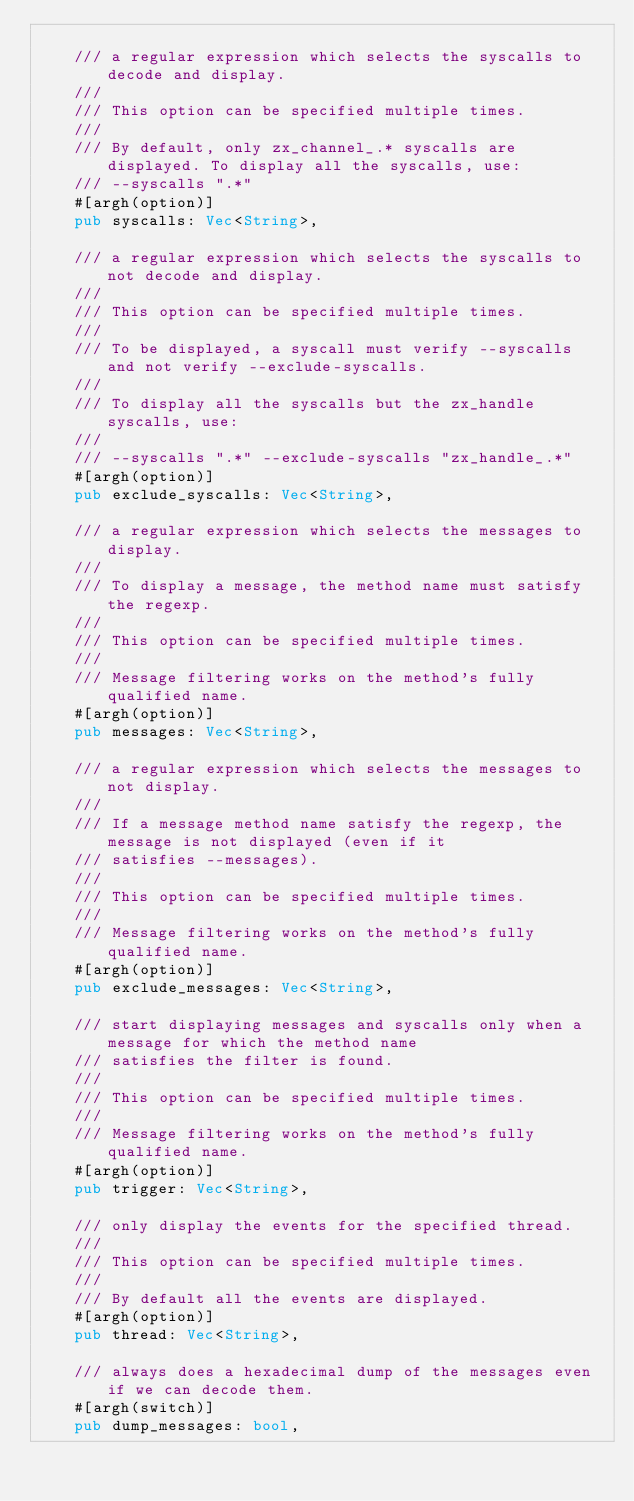Convert code to text. <code><loc_0><loc_0><loc_500><loc_500><_Rust_>
    /// a regular expression which selects the syscalls to decode and display.
    ///
    /// This option can be specified multiple times.
    ///
    /// By default, only zx_channel_.* syscalls are displayed. To display all the syscalls, use:
    /// --syscalls ".*"
    #[argh(option)]
    pub syscalls: Vec<String>,

    /// a regular expression which selects the syscalls to not decode and display.
    ///
    /// This option can be specified multiple times.
    ///
    /// To be displayed, a syscall must verify --syscalls and not verify --exclude-syscalls.
    ///
    /// To display all the syscalls but the zx_handle syscalls, use:
    ///
    /// --syscalls ".*" --exclude-syscalls "zx_handle_.*"
    #[argh(option)]
    pub exclude_syscalls: Vec<String>,

    /// a regular expression which selects the messages to display.
    ///
    /// To display a message, the method name must satisfy the regexp.
    ///
    /// This option can be specified multiple times.
    ///
    /// Message filtering works on the method's fully qualified name.
    #[argh(option)]
    pub messages: Vec<String>,

    /// a regular expression which selects the messages to not display.
    ///
    /// If a message method name satisfy the regexp, the message is not displayed (even if it
    /// satisfies --messages).
    ///
    /// This option can be specified multiple times.
    ///
    /// Message filtering works on the method's fully qualified name.
    #[argh(option)]
    pub exclude_messages: Vec<String>,

    /// start displaying messages and syscalls only when a message for which the method name
    /// satisfies the filter is found.
    ///
    /// This option can be specified multiple times.
    ///
    /// Message filtering works on the method's fully qualified name.
    #[argh(option)]
    pub trigger: Vec<String>,

    /// only display the events for the specified thread.
    ///
    /// This option can be specified multiple times.
    ///
    /// By default all the events are displayed.
    #[argh(option)]
    pub thread: Vec<String>,

    /// always does a hexadecimal dump of the messages even if we can decode them.
    #[argh(switch)]
    pub dump_messages: bool,
</code> 